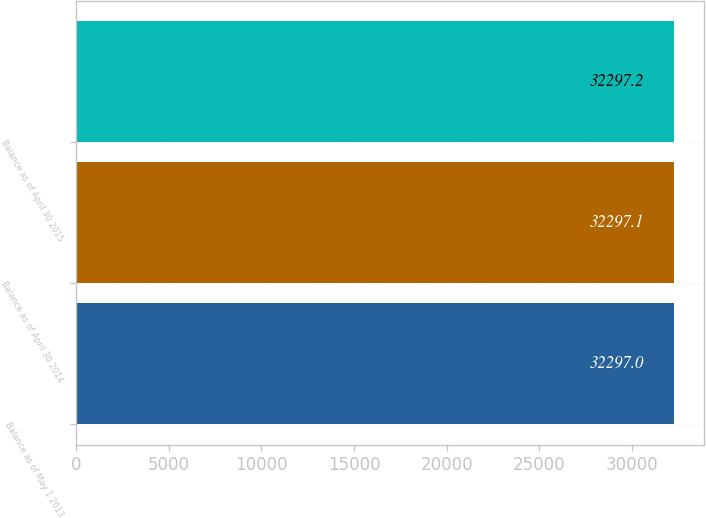<chart> <loc_0><loc_0><loc_500><loc_500><bar_chart><fcel>Balance as of May 1 2013<fcel>Balance as of April 30 2014<fcel>Balance as of April 30 2015<nl><fcel>32297<fcel>32297.1<fcel>32297.2<nl></chart> 